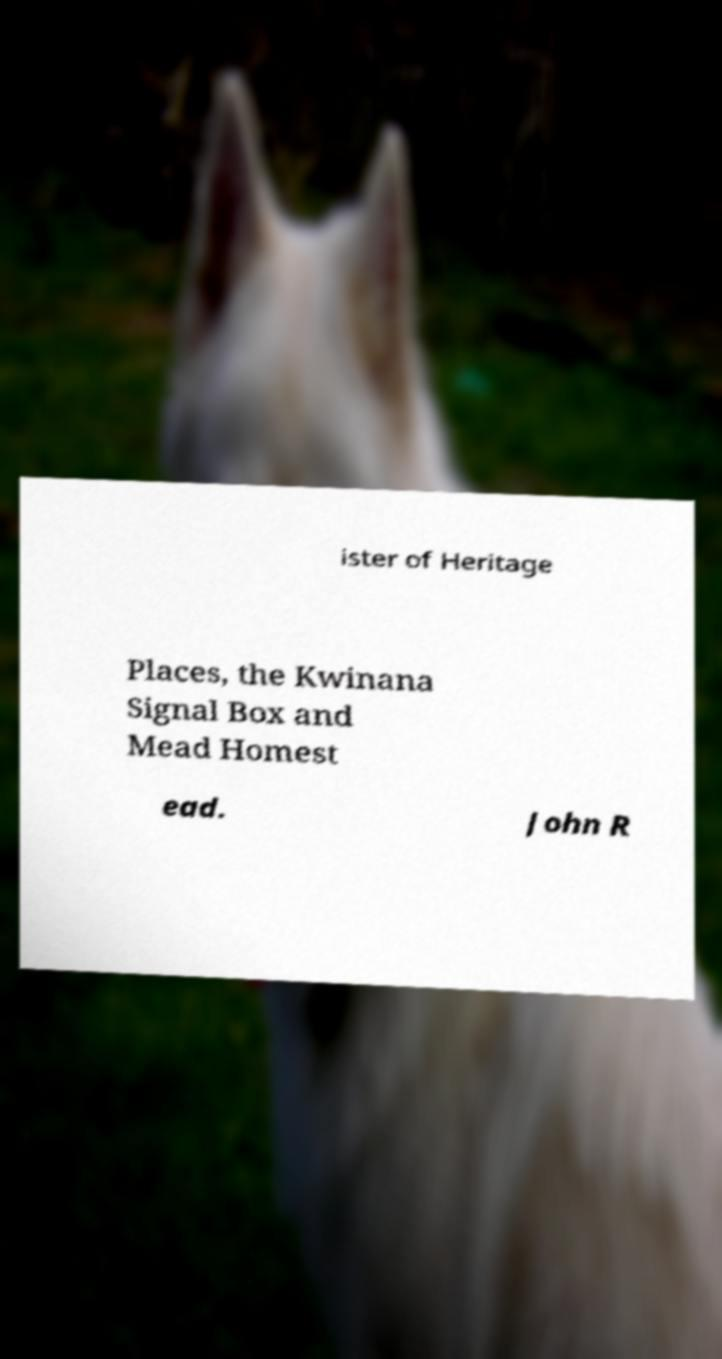I need the written content from this picture converted into text. Can you do that? ister of Heritage Places, the Kwinana Signal Box and Mead Homest ead. John R 